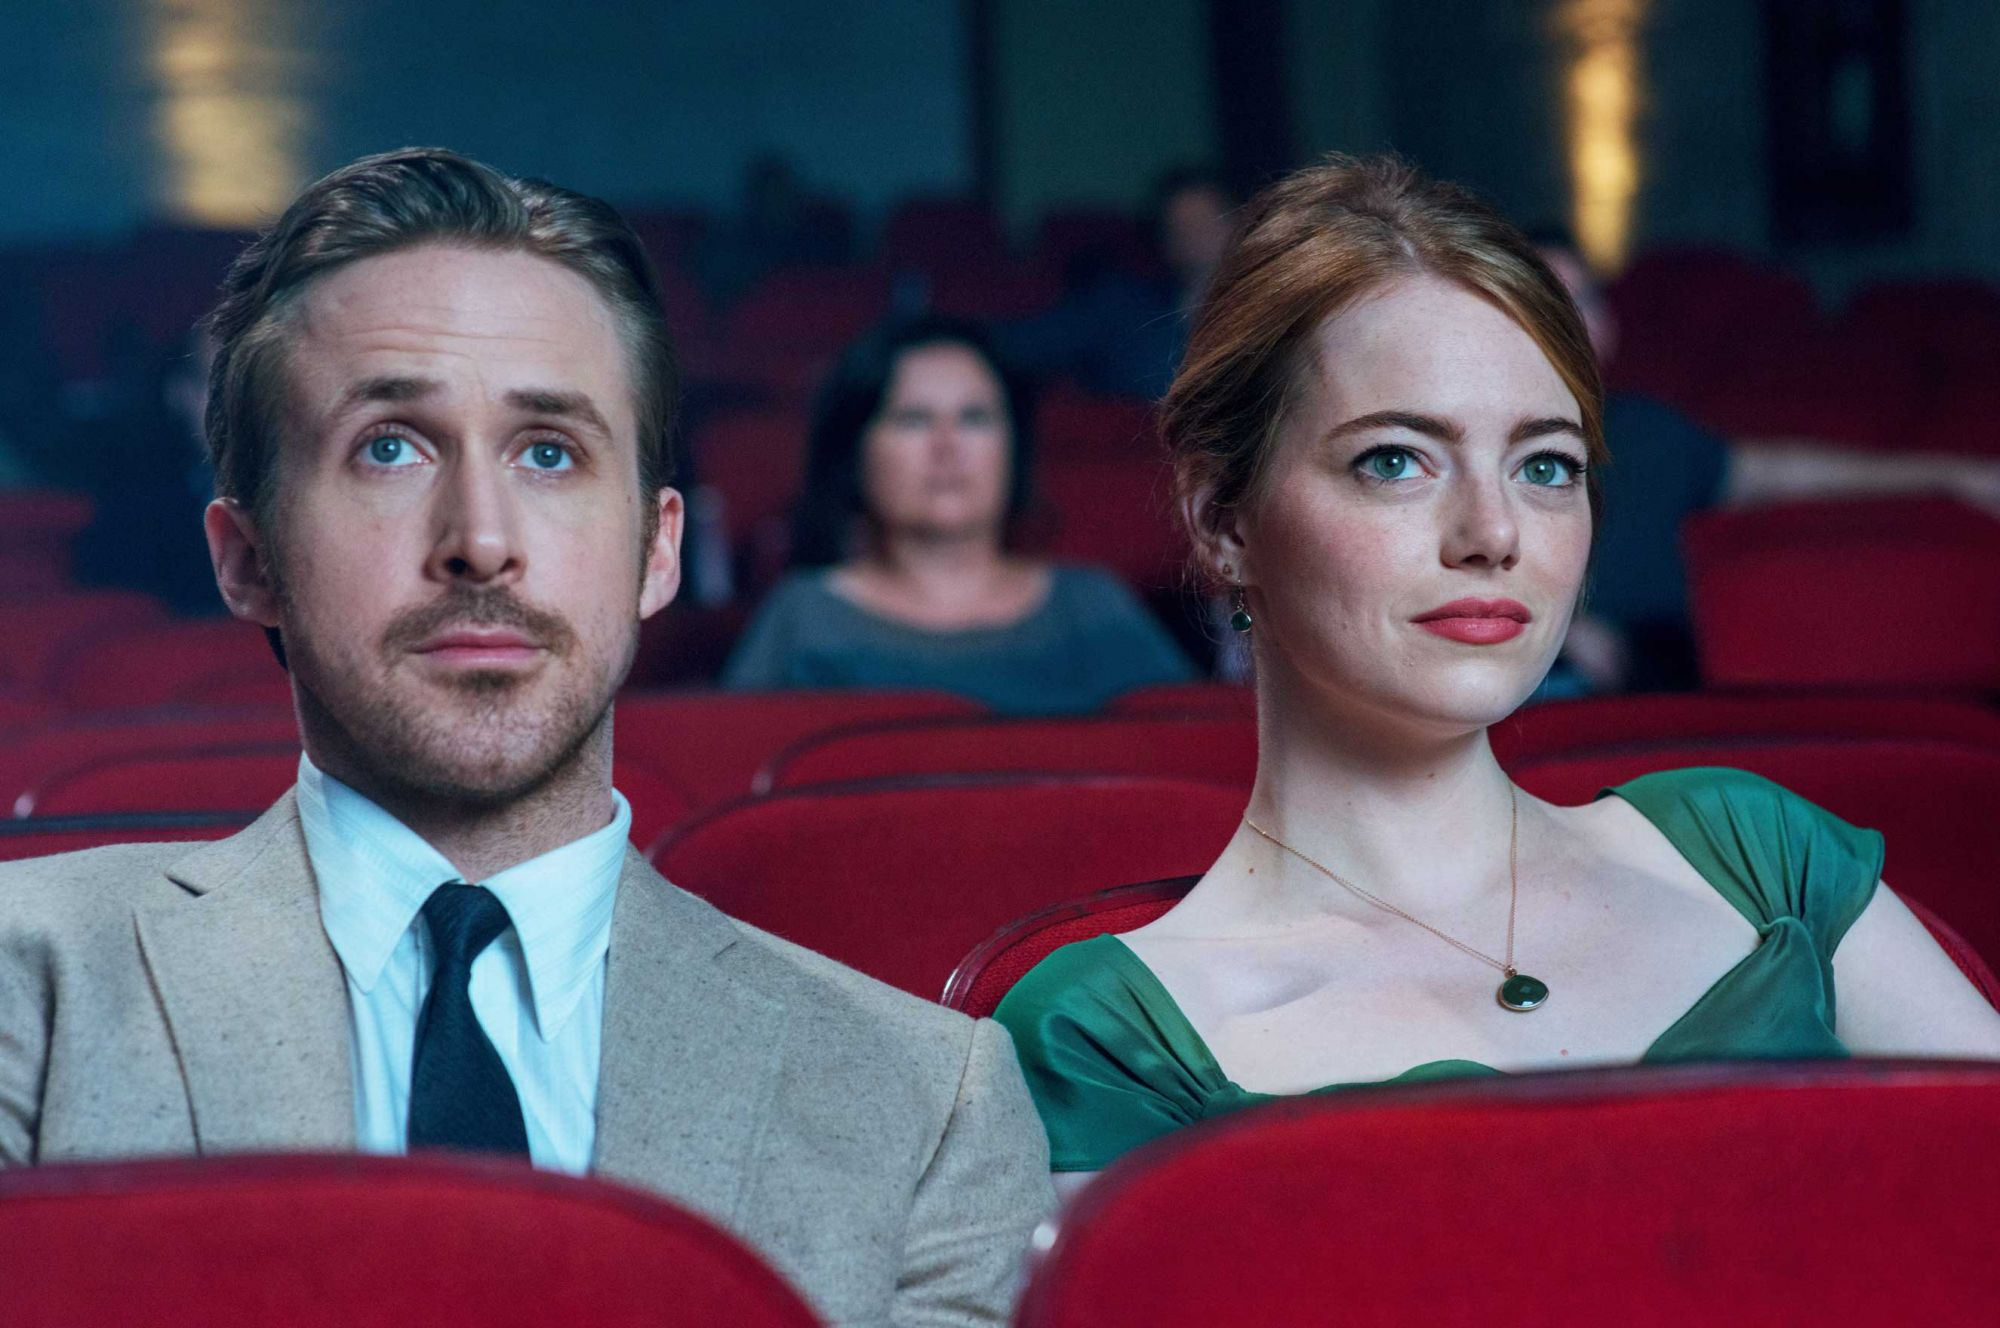If this image was a scene from a different genre, how would you imagine it? If this image was from a science fiction genre, Sebastian and Mia could be watching a futuristic holographic movie, with advanced technology transforming the theater into a vibrant, interactive experience. Their expressions of awe would be directed at a dazzling display of interstellar voyages and advanced civilizations, with the theater’s ambiance reflecting an otherworldly glow. The blurred background would feature futuristic elements, enhancing the sense of immersion in a sci-fi adventure. 